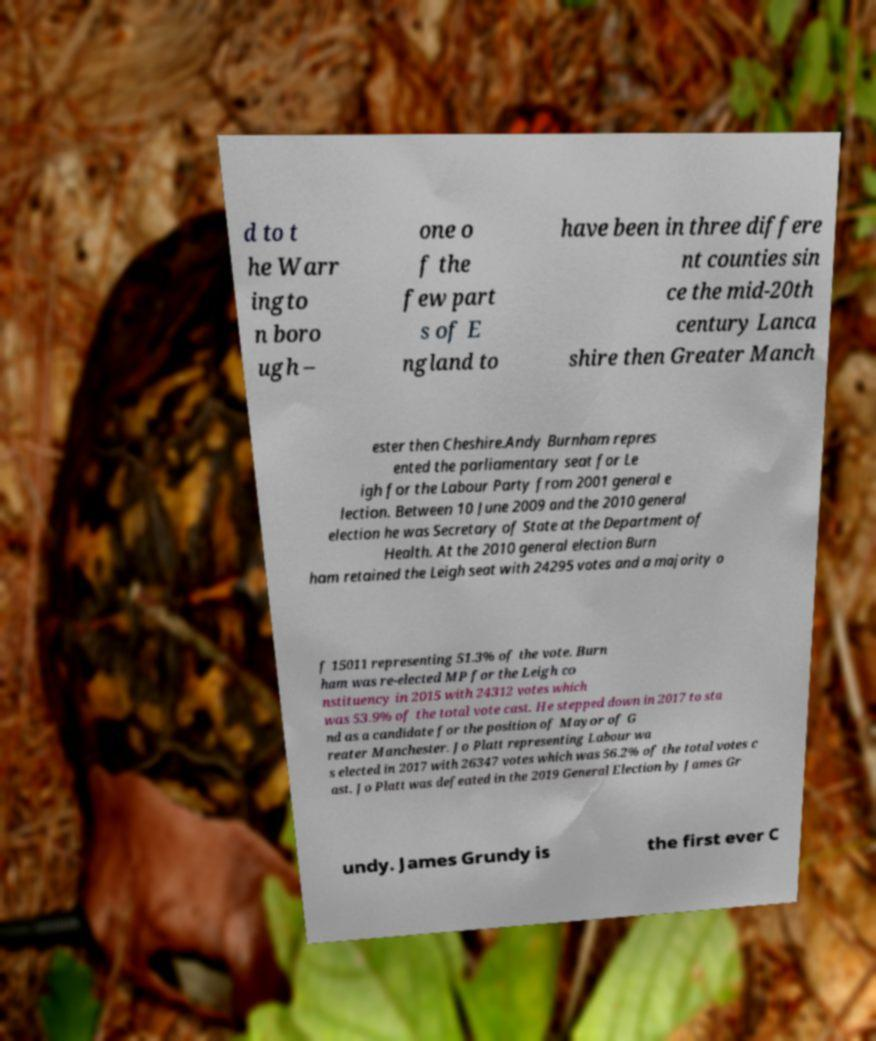Could you assist in decoding the text presented in this image and type it out clearly? d to t he Warr ingto n boro ugh – one o f the few part s of E ngland to have been in three differe nt counties sin ce the mid-20th century Lanca shire then Greater Manch ester then Cheshire.Andy Burnham repres ented the parliamentary seat for Le igh for the Labour Party from 2001 general e lection. Between 10 June 2009 and the 2010 general election he was Secretary of State at the Department of Health. At the 2010 general election Burn ham retained the Leigh seat with 24295 votes and a majority o f 15011 representing 51.3% of the vote. Burn ham was re-elected MP for the Leigh co nstituency in 2015 with 24312 votes which was 53.9% of the total vote cast. He stepped down in 2017 to sta nd as a candidate for the position of Mayor of G reater Manchester. Jo Platt representing Labour wa s elected in 2017 with 26347 votes which was 56.2% of the total votes c ast. Jo Platt was defeated in the 2019 General Election by James Gr undy. James Grundy is the first ever C 